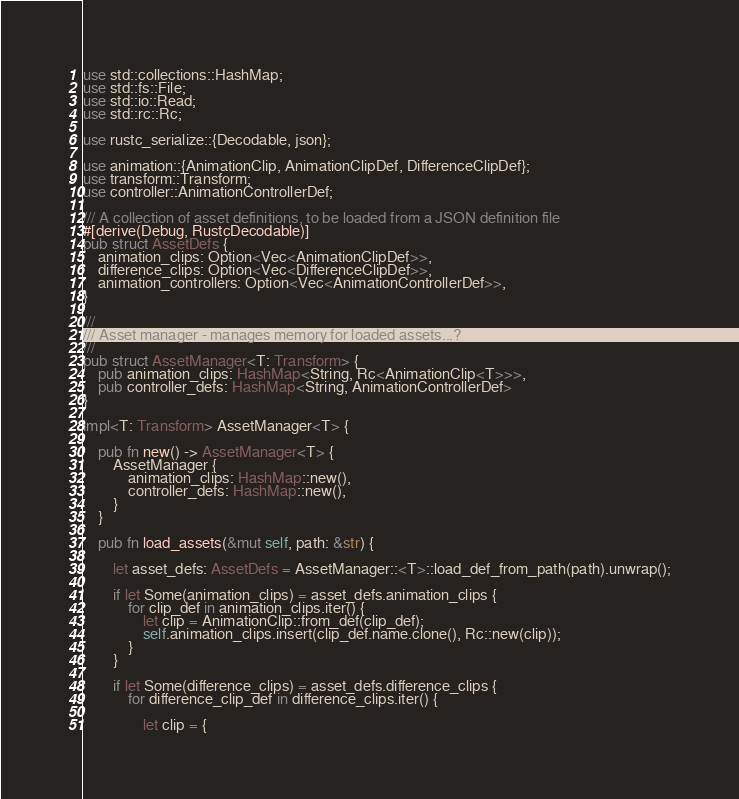Convert code to text. <code><loc_0><loc_0><loc_500><loc_500><_Rust_>use std::collections::HashMap;
use std::fs::File;
use std::io::Read;
use std::rc::Rc;

use rustc_serialize::{Decodable, json};

use animation::{AnimationClip, AnimationClipDef, DifferenceClipDef};
use transform::Transform;
use controller::AnimationControllerDef;

/// A collection of asset definitions, to be loaded from a JSON definition file
#[derive(Debug, RustcDecodable)]
pub struct AssetDefs {
    animation_clips: Option<Vec<AnimationClipDef>>,
    difference_clips: Option<Vec<DifferenceClipDef>>,
    animation_controllers: Option<Vec<AnimationControllerDef>>,
}

///
/// Asset manager - manages memory for loaded assets...?
///
pub struct AssetManager<T: Transform> {
    pub animation_clips: HashMap<String, Rc<AnimationClip<T>>>,
    pub controller_defs: HashMap<String, AnimationControllerDef>
}

impl<T: Transform> AssetManager<T> {

    pub fn new() -> AssetManager<T> {
        AssetManager {
            animation_clips: HashMap::new(),
            controller_defs: HashMap::new(),
        }
    }

    pub fn load_assets(&mut self, path: &str) {

        let asset_defs: AssetDefs = AssetManager::<T>::load_def_from_path(path).unwrap();

        if let Some(animation_clips) = asset_defs.animation_clips {
            for clip_def in animation_clips.iter() {
                let clip = AnimationClip::from_def(clip_def);
                self.animation_clips.insert(clip_def.name.clone(), Rc::new(clip));
            }
        }

        if let Some(difference_clips) = asset_defs.difference_clips {
            for difference_clip_def in difference_clips.iter() {

                let clip = {</code> 